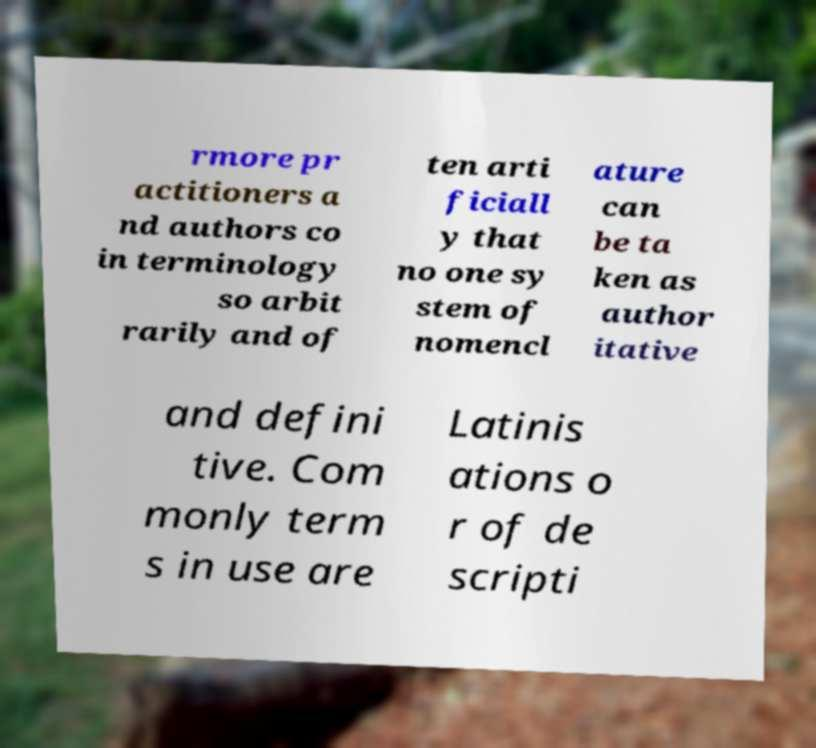Please identify and transcribe the text found in this image. rmore pr actitioners a nd authors co in terminology so arbit rarily and of ten arti ficiall y that no one sy stem of nomencl ature can be ta ken as author itative and defini tive. Com monly term s in use are Latinis ations o r of de scripti 